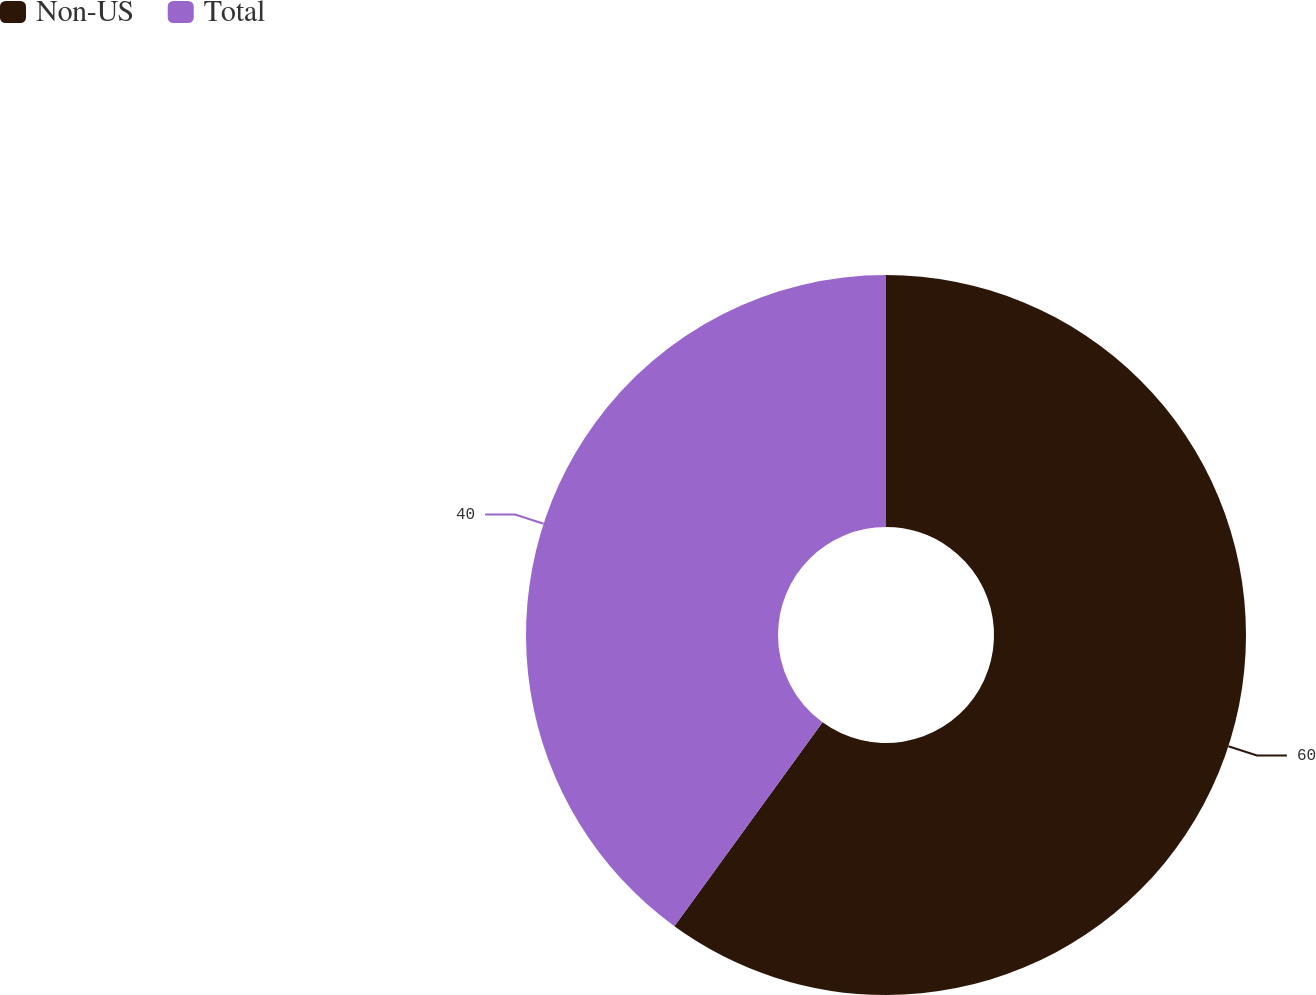<chart> <loc_0><loc_0><loc_500><loc_500><pie_chart><fcel>Non-US<fcel>Total<nl><fcel>60.0%<fcel>40.0%<nl></chart> 